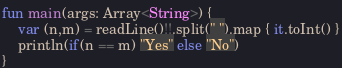Convert code to text. <code><loc_0><loc_0><loc_500><loc_500><_Kotlin_>fun main(args: Array<String>) {
    var (n,m) = readLine()!!.split(" ").map { it.toInt() }
    println(if(n == m) "Yes" else "No")
}
</code> 